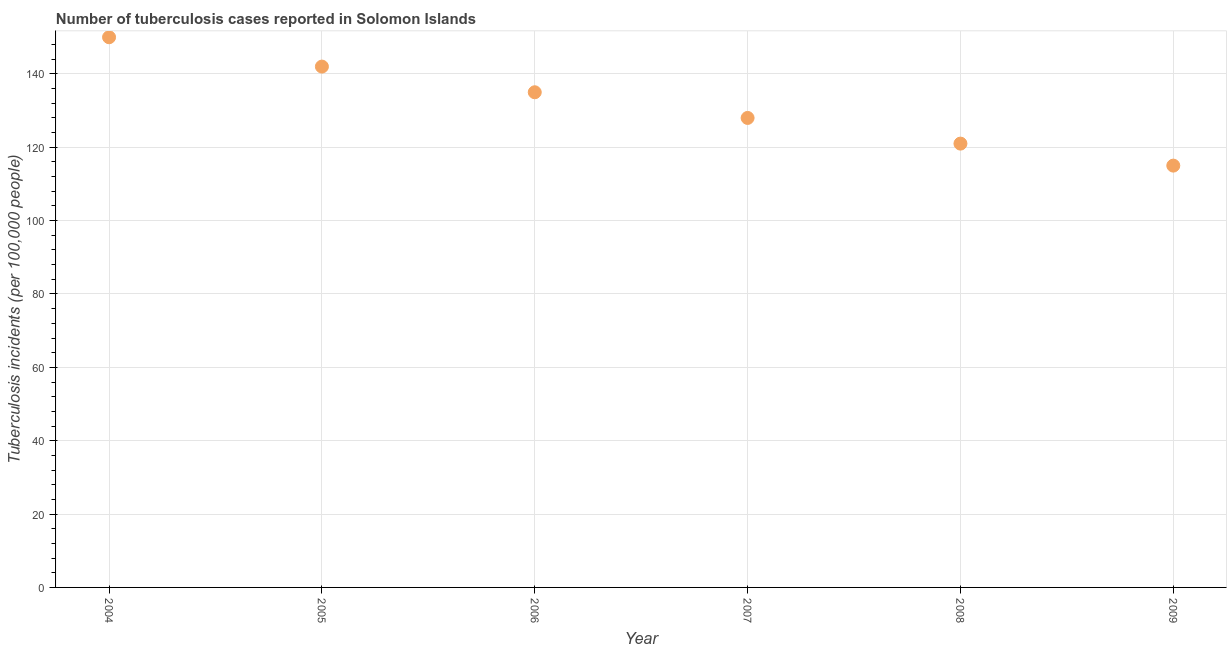What is the number of tuberculosis incidents in 2009?
Offer a very short reply. 115. Across all years, what is the maximum number of tuberculosis incidents?
Ensure brevity in your answer.  150. Across all years, what is the minimum number of tuberculosis incidents?
Provide a short and direct response. 115. In which year was the number of tuberculosis incidents minimum?
Provide a succinct answer. 2009. What is the sum of the number of tuberculosis incidents?
Offer a terse response. 791. What is the difference between the number of tuberculosis incidents in 2004 and 2006?
Your answer should be compact. 15. What is the average number of tuberculosis incidents per year?
Provide a short and direct response. 131.83. What is the median number of tuberculosis incidents?
Offer a terse response. 131.5. In how many years, is the number of tuberculosis incidents greater than 28 ?
Keep it short and to the point. 6. What is the ratio of the number of tuberculosis incidents in 2005 to that in 2007?
Your response must be concise. 1.11. Is the difference between the number of tuberculosis incidents in 2006 and 2008 greater than the difference between any two years?
Your response must be concise. No. What is the difference between the highest and the second highest number of tuberculosis incidents?
Provide a short and direct response. 8. Is the sum of the number of tuberculosis incidents in 2005 and 2007 greater than the maximum number of tuberculosis incidents across all years?
Provide a short and direct response. Yes. What is the difference between the highest and the lowest number of tuberculosis incidents?
Your response must be concise. 35. In how many years, is the number of tuberculosis incidents greater than the average number of tuberculosis incidents taken over all years?
Keep it short and to the point. 3. Does the number of tuberculosis incidents monotonically increase over the years?
Give a very brief answer. No. How many dotlines are there?
Your response must be concise. 1. What is the difference between two consecutive major ticks on the Y-axis?
Your answer should be compact. 20. Are the values on the major ticks of Y-axis written in scientific E-notation?
Provide a succinct answer. No. What is the title of the graph?
Make the answer very short. Number of tuberculosis cases reported in Solomon Islands. What is the label or title of the Y-axis?
Your response must be concise. Tuberculosis incidents (per 100,0 people). What is the Tuberculosis incidents (per 100,000 people) in 2004?
Keep it short and to the point. 150. What is the Tuberculosis incidents (per 100,000 people) in 2005?
Ensure brevity in your answer.  142. What is the Tuberculosis incidents (per 100,000 people) in 2006?
Offer a terse response. 135. What is the Tuberculosis incidents (per 100,000 people) in 2007?
Your response must be concise. 128. What is the Tuberculosis incidents (per 100,000 people) in 2008?
Provide a short and direct response. 121. What is the Tuberculosis incidents (per 100,000 people) in 2009?
Your response must be concise. 115. What is the difference between the Tuberculosis incidents (per 100,000 people) in 2004 and 2005?
Your answer should be very brief. 8. What is the difference between the Tuberculosis incidents (per 100,000 people) in 2004 and 2006?
Ensure brevity in your answer.  15. What is the difference between the Tuberculosis incidents (per 100,000 people) in 2004 and 2007?
Offer a very short reply. 22. What is the difference between the Tuberculosis incidents (per 100,000 people) in 2004 and 2009?
Provide a short and direct response. 35. What is the difference between the Tuberculosis incidents (per 100,000 people) in 2005 and 2007?
Make the answer very short. 14. What is the difference between the Tuberculosis incidents (per 100,000 people) in 2005 and 2008?
Your answer should be compact. 21. What is the difference between the Tuberculosis incidents (per 100,000 people) in 2006 and 2007?
Give a very brief answer. 7. What is the difference between the Tuberculosis incidents (per 100,000 people) in 2006 and 2008?
Ensure brevity in your answer.  14. What is the difference between the Tuberculosis incidents (per 100,000 people) in 2006 and 2009?
Your answer should be compact. 20. What is the difference between the Tuberculosis incidents (per 100,000 people) in 2007 and 2009?
Offer a very short reply. 13. What is the difference between the Tuberculosis incidents (per 100,000 people) in 2008 and 2009?
Provide a short and direct response. 6. What is the ratio of the Tuberculosis incidents (per 100,000 people) in 2004 to that in 2005?
Offer a terse response. 1.06. What is the ratio of the Tuberculosis incidents (per 100,000 people) in 2004 to that in 2006?
Make the answer very short. 1.11. What is the ratio of the Tuberculosis incidents (per 100,000 people) in 2004 to that in 2007?
Offer a terse response. 1.17. What is the ratio of the Tuberculosis incidents (per 100,000 people) in 2004 to that in 2008?
Your answer should be very brief. 1.24. What is the ratio of the Tuberculosis incidents (per 100,000 people) in 2004 to that in 2009?
Provide a short and direct response. 1.3. What is the ratio of the Tuberculosis incidents (per 100,000 people) in 2005 to that in 2006?
Ensure brevity in your answer.  1.05. What is the ratio of the Tuberculosis incidents (per 100,000 people) in 2005 to that in 2007?
Make the answer very short. 1.11. What is the ratio of the Tuberculosis incidents (per 100,000 people) in 2005 to that in 2008?
Your response must be concise. 1.17. What is the ratio of the Tuberculosis incidents (per 100,000 people) in 2005 to that in 2009?
Your answer should be compact. 1.24. What is the ratio of the Tuberculosis incidents (per 100,000 people) in 2006 to that in 2007?
Give a very brief answer. 1.05. What is the ratio of the Tuberculosis incidents (per 100,000 people) in 2006 to that in 2008?
Your answer should be compact. 1.12. What is the ratio of the Tuberculosis incidents (per 100,000 people) in 2006 to that in 2009?
Offer a terse response. 1.17. What is the ratio of the Tuberculosis incidents (per 100,000 people) in 2007 to that in 2008?
Your answer should be compact. 1.06. What is the ratio of the Tuberculosis incidents (per 100,000 people) in 2007 to that in 2009?
Give a very brief answer. 1.11. What is the ratio of the Tuberculosis incidents (per 100,000 people) in 2008 to that in 2009?
Provide a short and direct response. 1.05. 